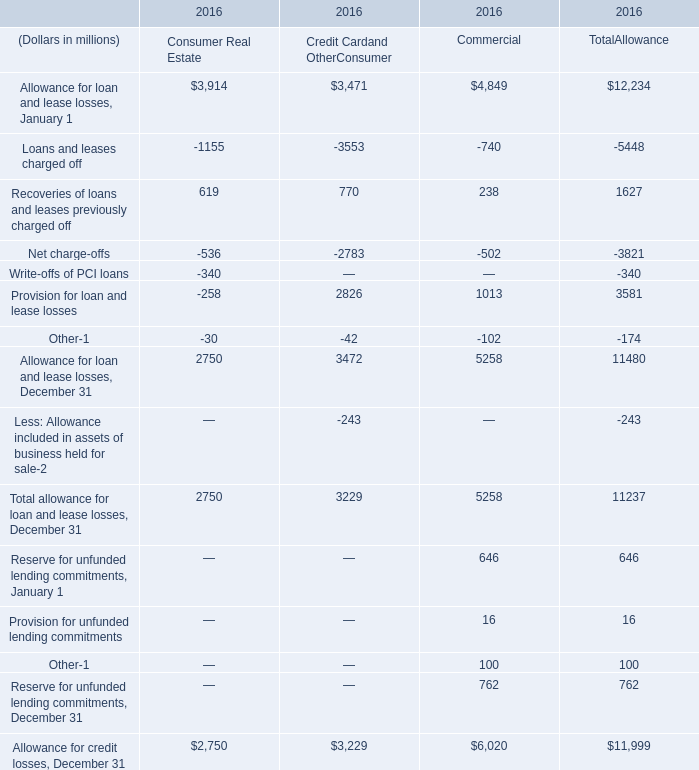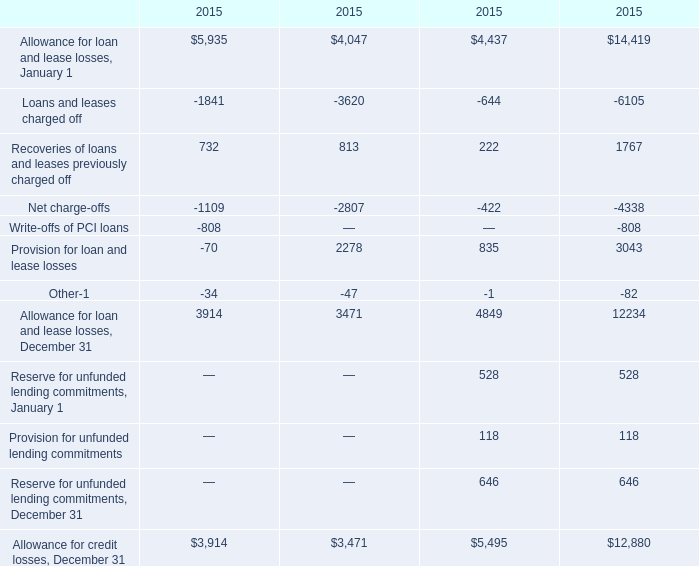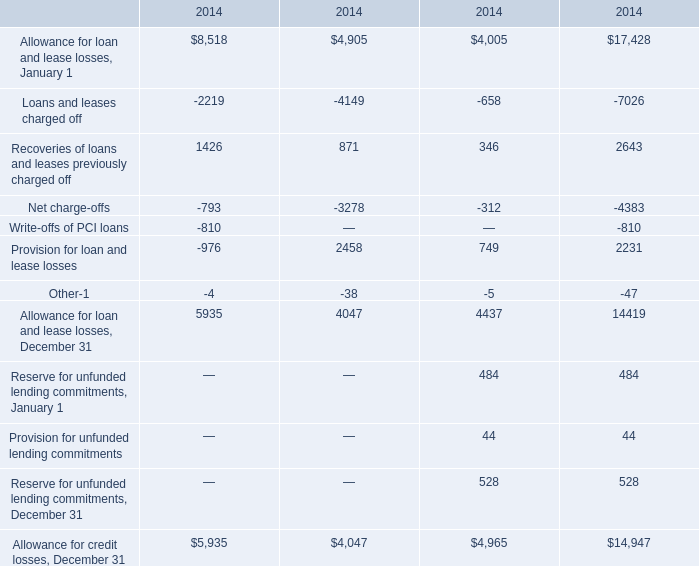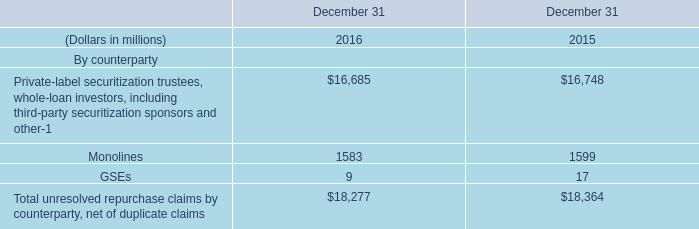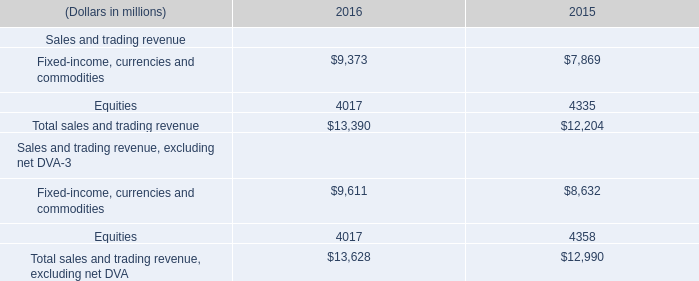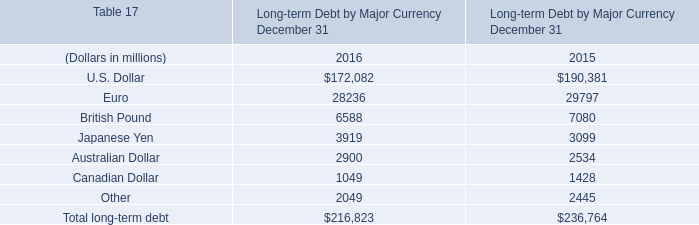Which year is Allowance for credit losses, December 31 greater than 10000 ? 
Answer: 2014. 